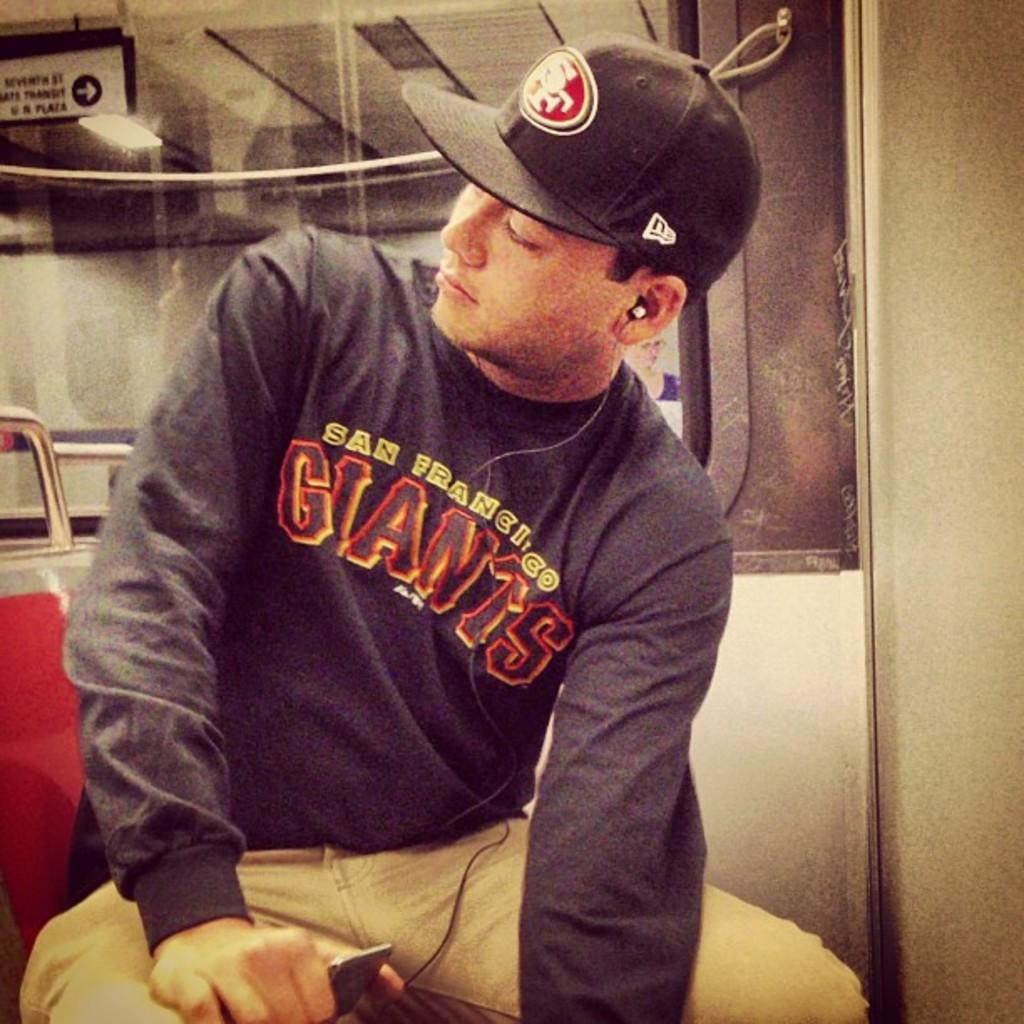Provide a one-sentence caption for the provided image. Man sitting with a San Francisco Giants shirt on. 